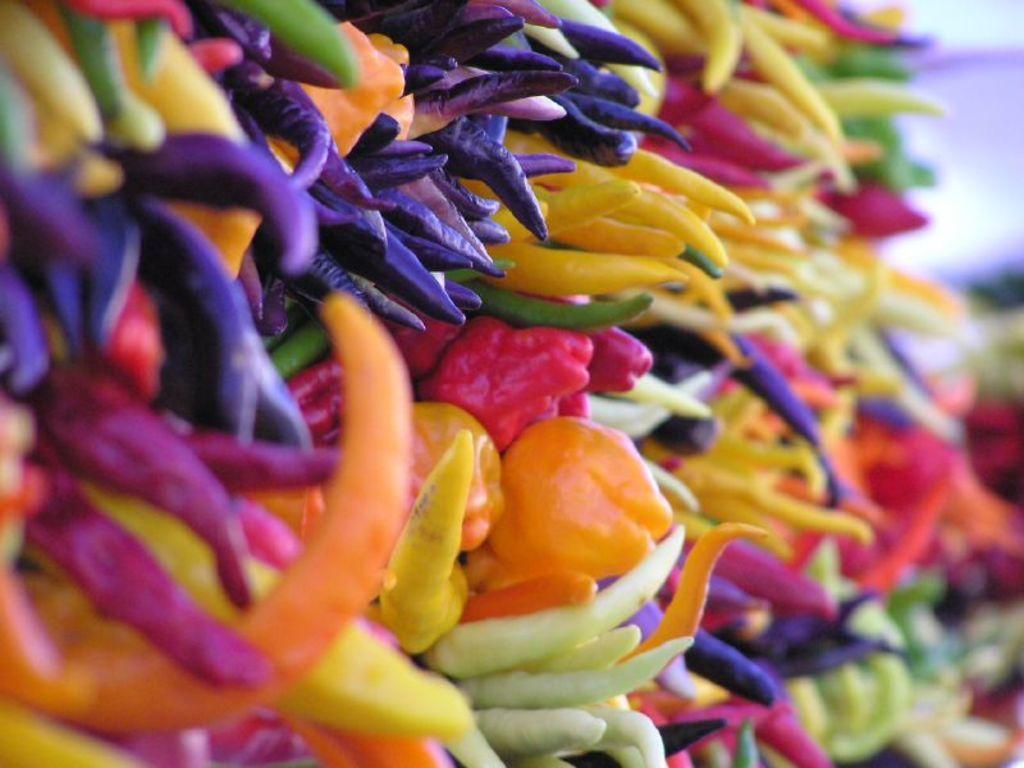Please provide a concise description of this image. Here we can see different colors of chilies. 